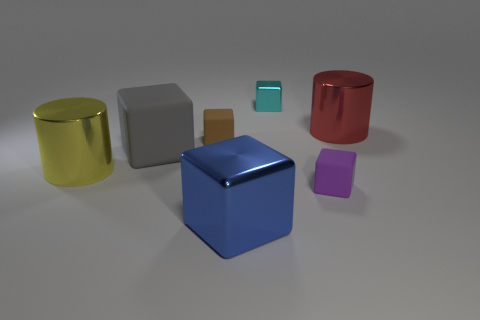Is the number of big red objects greater than the number of metallic blocks?
Your response must be concise. No. Are there any yellow cylinders of the same size as the brown object?
Give a very brief answer. No. How many things are large things behind the big yellow cylinder or matte things to the left of the blue shiny object?
Offer a terse response. 3. What is the color of the big metallic cylinder that is in front of the cylinder that is right of the blue shiny block?
Provide a succinct answer. Yellow. There is a small thing that is the same material as the small brown block; what color is it?
Offer a terse response. Purple. How many objects are big cubes or small gray metal things?
Offer a very short reply. 2. What is the shape of the red object that is the same size as the blue thing?
Give a very brief answer. Cylinder. What number of small things are both on the right side of the brown cube and in front of the cyan block?
Provide a succinct answer. 1. There is a small thing that is in front of the large gray cube; what material is it?
Make the answer very short. Rubber. What size is the blue object that is the same material as the big red thing?
Your answer should be compact. Large. 